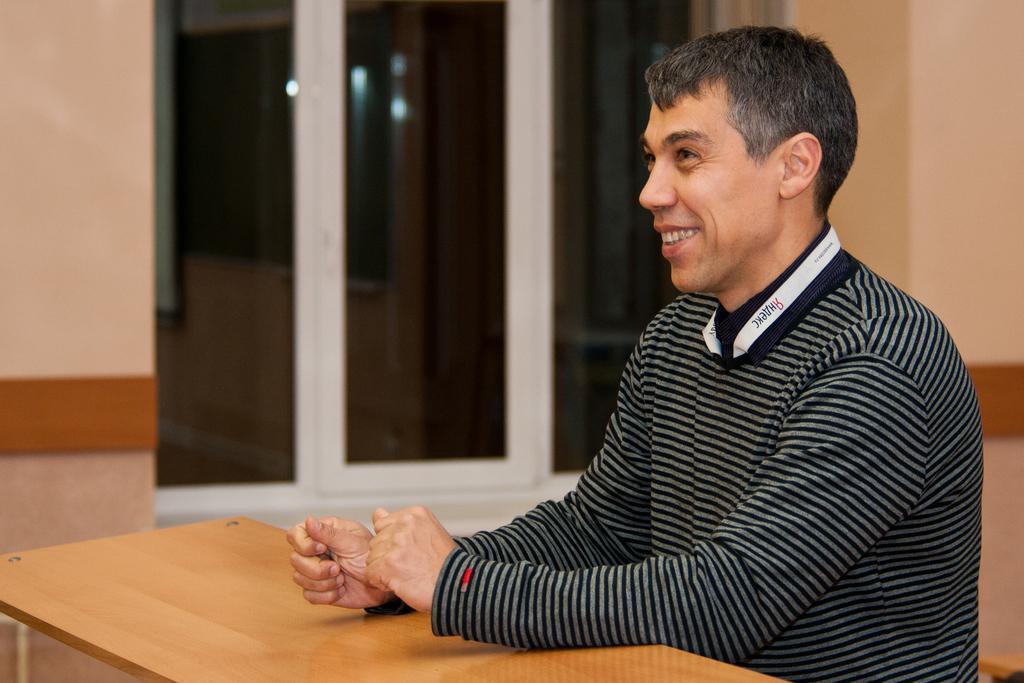Describe this image in one or two sentences. This picture shows a man seated and we see a table and a window and we see smile on his face. 